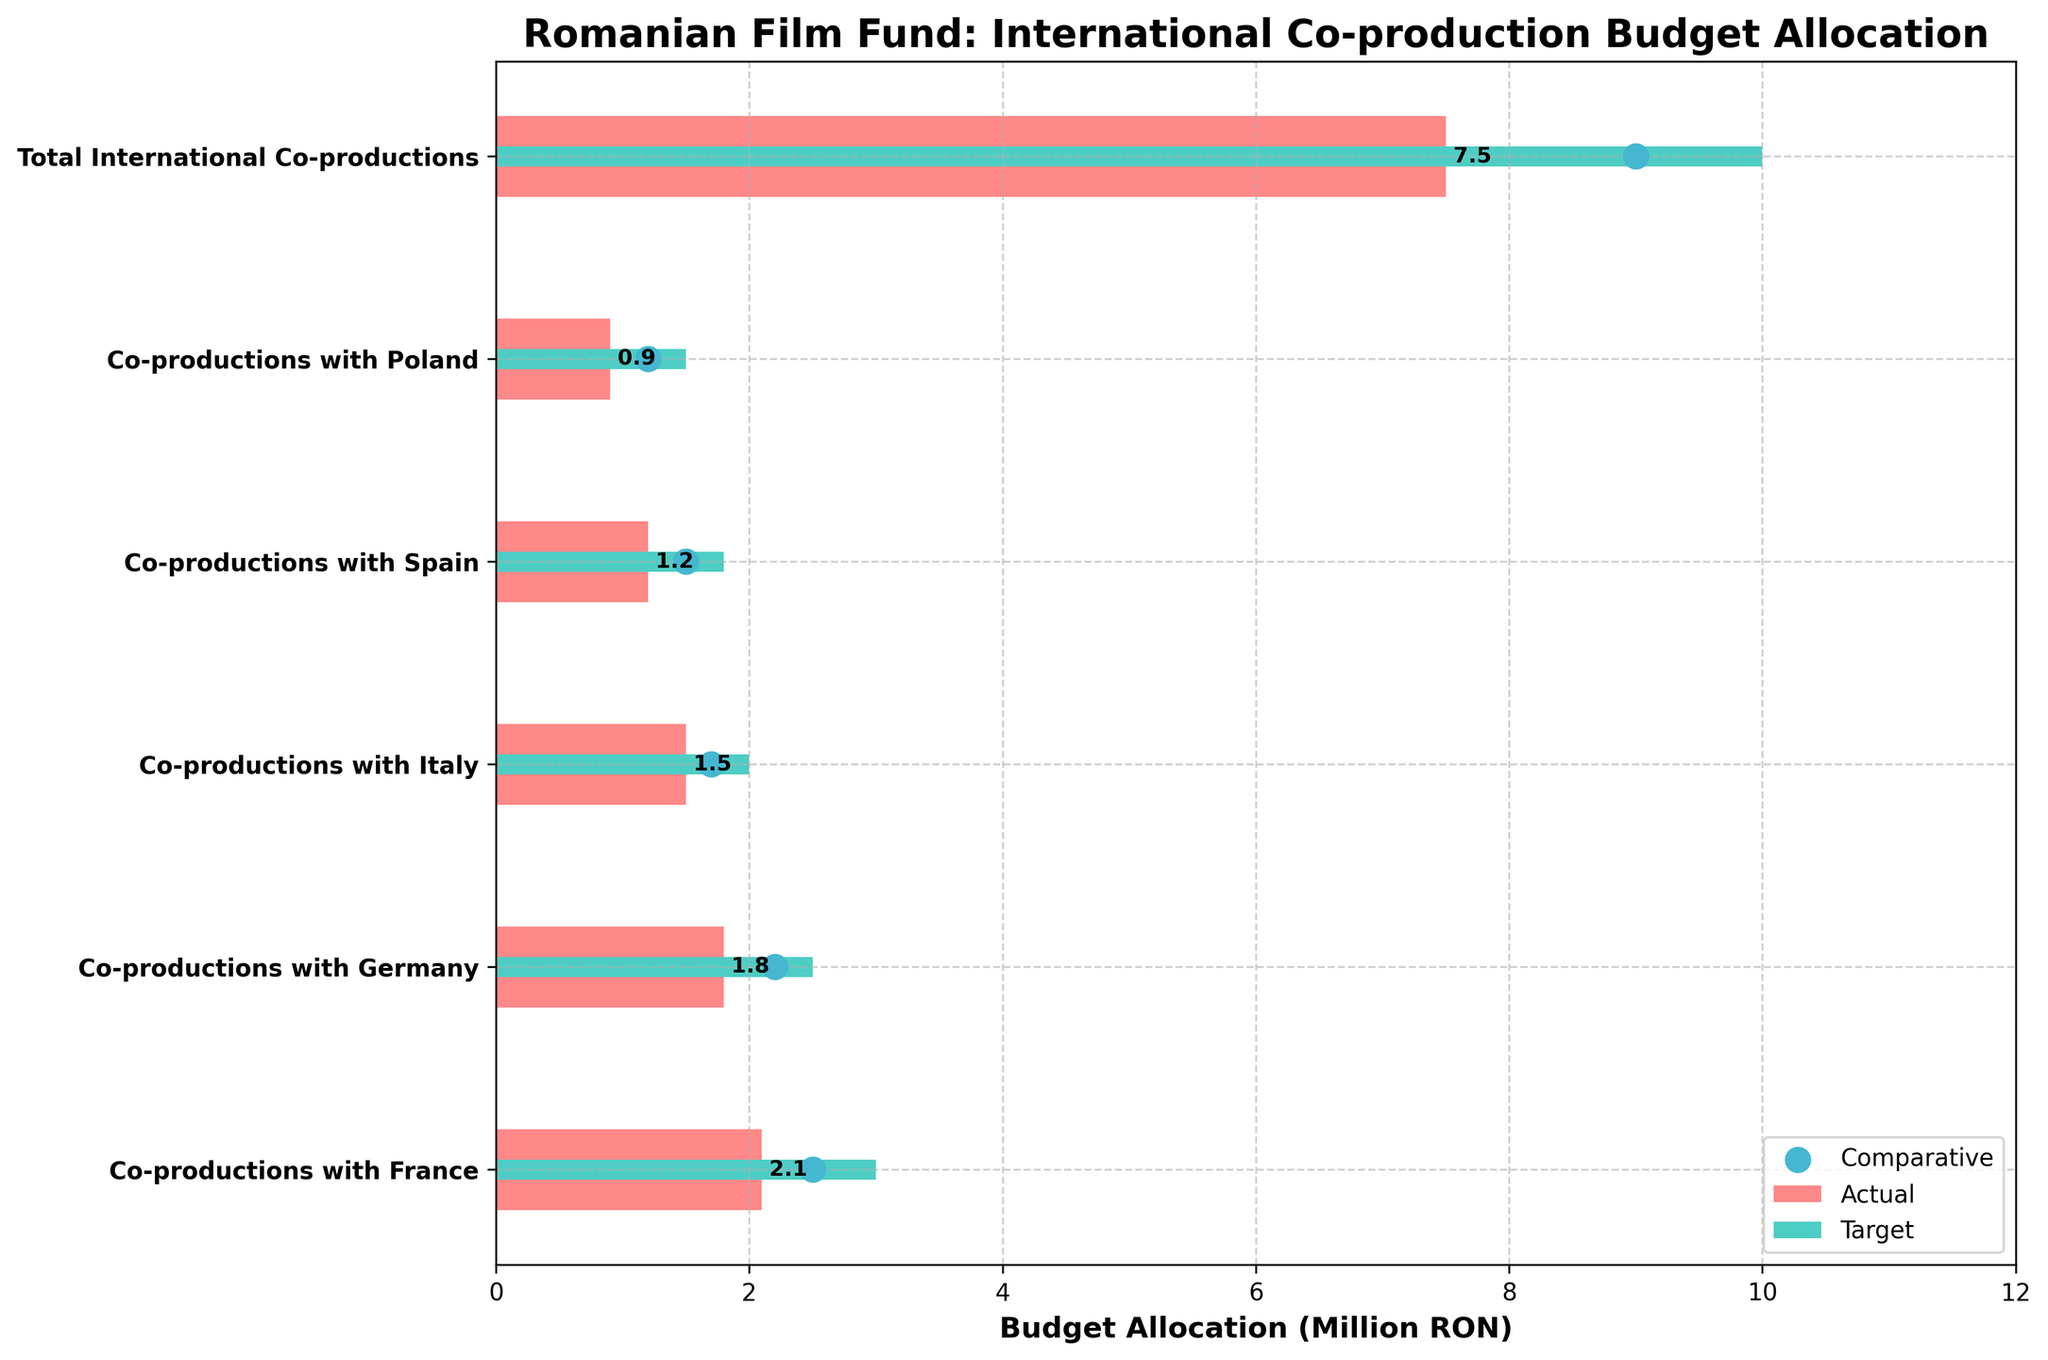What is the title of the plot? The title of the plot is typically located at the top center of the figure and directly provides the main subject of the chart. In this case, it's easily readable, stating the focus on budget allocation.
Answer: Romanian Film Fund: International Co-production Budget Allocation How much was the actual budget for co-productions with France? To determine the actual budget, look at the bar corresponding to "Co-productions with France." The bar's endpoint indicates the actual budget.
Answer: 2.1 million RON Which co-production category had the biggest difference between the target and actual budget allocation? To find this, calculate the differences between the target and actual budgets for all categories: (3.0 - 2.1) for France, (2.5 - 1.8) for Germany, (2.0 - 1.5) for Italy, (1.8 - 1.2) for Spain, and (1.5 - 0.9) for Poland. Compare these values to determine the maximum difference.
Answer: Co-productions with France What is the comparative measure for co-productions with Italy? Locate the “Co-productions with Italy” row on the chart, and identify the location of the marked dot, which represents the comparative measure.
Answer: 1.7 million RON Did any co-production category meet or exceed its target budget allocation? Review each category and compare the actual budget bars to their respective targets. If any bar reaches or goes past the green target bar, that category met/exceeded its target. None of the bars do so.
Answer: No Which co-production category has the smallest actual budget? Compare the lengths of the actual budget bars for each category. The shortest bar represents the smallest budget.
Answer: Co-productions with Poland What is the total target budget for all international co-productions, and how does it compare to the total actual budget? Sum the target budgets for each co-production category: 3.0 (France) + 2.5 (Germany) + 2.0 (Italy) + 1.8 (Spain) + 1.5 (Poland) = 10.8 million RON. Compare this with the total actual budget given (7.5 million RON).
Answer: Total target: 10.0 million RON, Total actual: 7.5 million RON By how much did the actual total budget for international co-productions fall short of the target? Subtract the total actual budget from the total target budget: 10.0 million RON (target) - 7.5 million RON (actual) = 2.5 million RON.
Answer: 2.5 million RON 